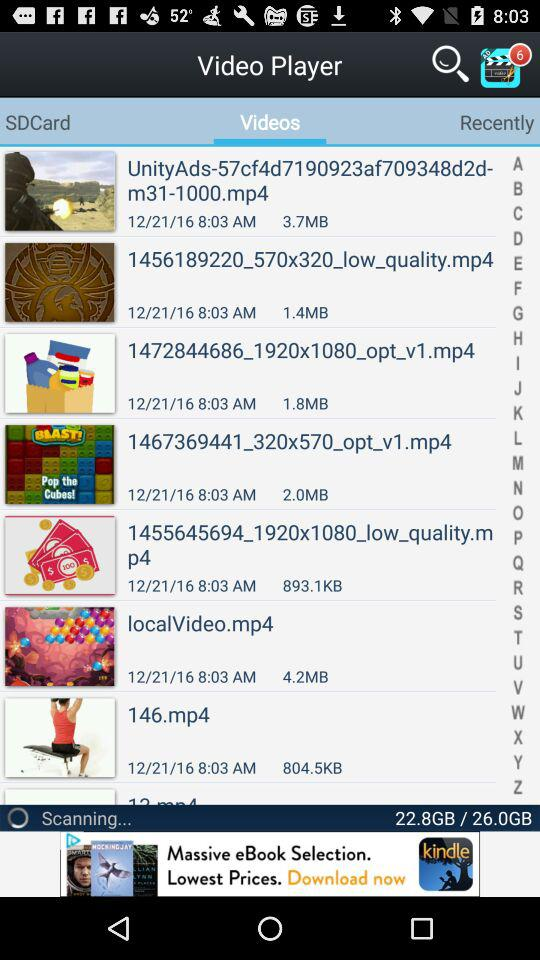Which video has the largest file size?
Answer the question using a single word or phrase. LocalVideo.mp4 